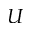Convert formula to latex. <formula><loc_0><loc_0><loc_500><loc_500>U</formula> 